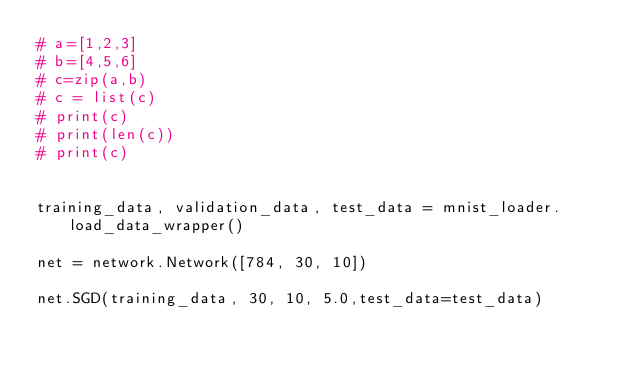Convert code to text. <code><loc_0><loc_0><loc_500><loc_500><_Python_># a=[1,2,3]
# b=[4,5,6]
# c=zip(a,b)
# c = list(c)
# print(c)
# print(len(c))
# print(c)


training_data, validation_data, test_data = mnist_loader.load_data_wrapper()

net = network.Network([784, 30, 10])

net.SGD(training_data, 30, 10, 5.0,test_data=test_data)</code> 